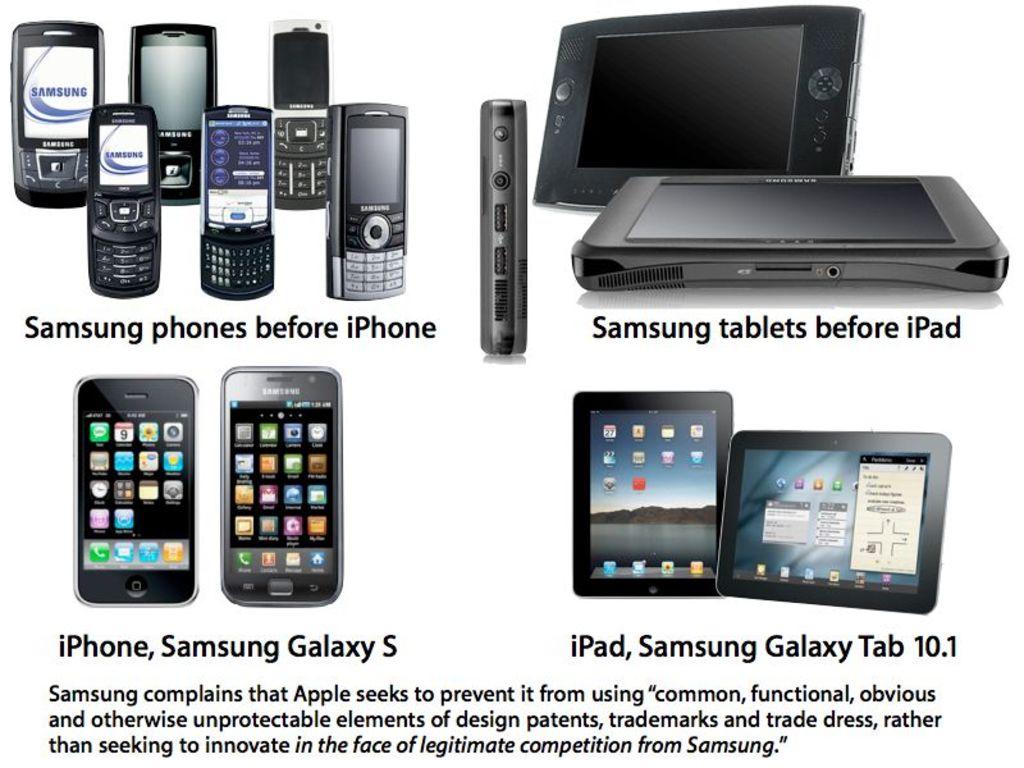What's the newest samsung model there?
Keep it short and to the point. Samsung galaxy tab 10.1. What two brands are mentioned in the ad?
Offer a terse response. Samsung and apple. 